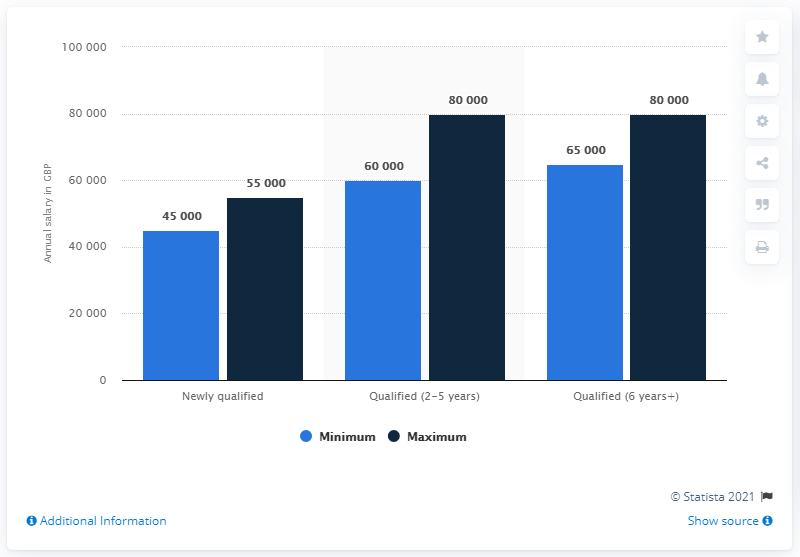List a handful of essential elements in this visual. The annual salary of newly qualified employees is 100000. The newly qualified qualification has a GBP increase of 10000 compared to the previous qualification, which has led to a significant increase in salary. 